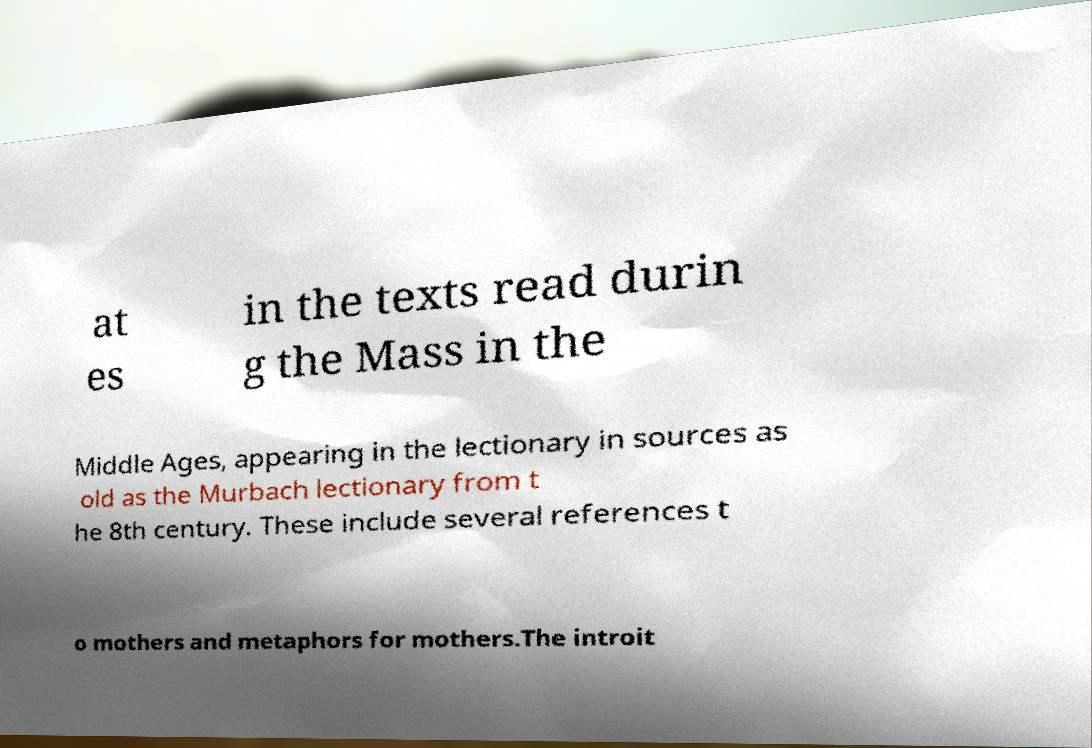Please read and relay the text visible in this image. What does it say? at es in the texts read durin g the Mass in the Middle Ages, appearing in the lectionary in sources as old as the Murbach lectionary from t he 8th century. These include several references t o mothers and metaphors for mothers.The introit 